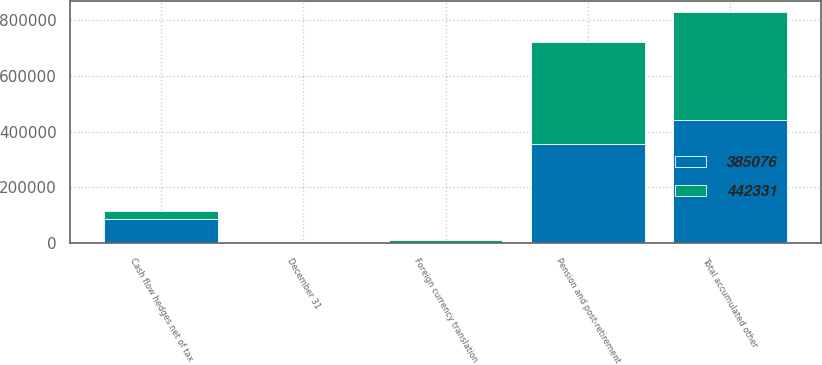Convert chart to OTSL. <chart><loc_0><loc_0><loc_500><loc_500><stacked_bar_chart><ecel><fcel>December 31<fcel>Foreign currency translation<fcel>Pension and post-retirement<fcel>Cash flow hedges net of tax<fcel>Total accumulated other<nl><fcel>442331<fcel>2012<fcel>9173<fcel>366037<fcel>28212<fcel>385076<nl><fcel>385076<fcel>2011<fcel>1459<fcel>356403<fcel>87387<fcel>442331<nl></chart> 